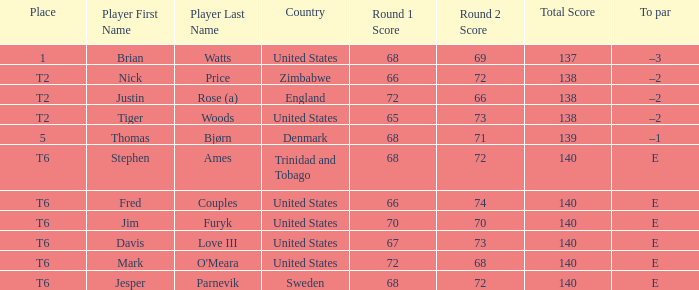Which country's player achieved a score of 66-72=138? Zimbabwe. 